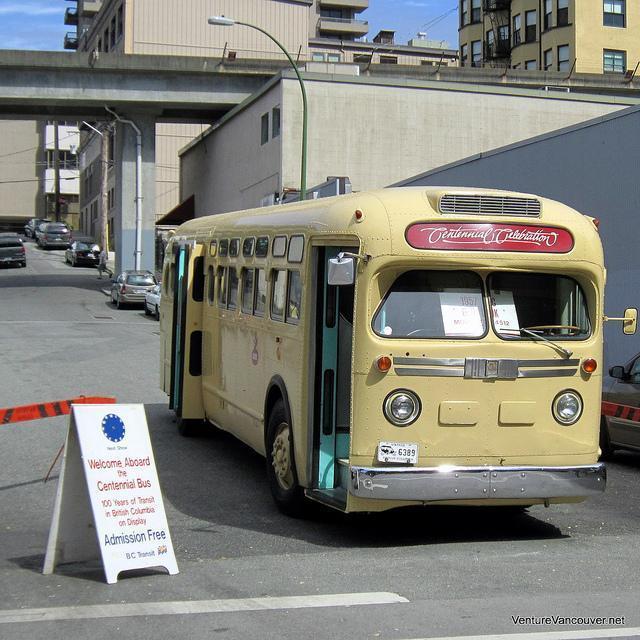How many people are wearing helmet?
Give a very brief answer. 0. 